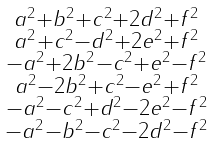Convert formula to latex. <formula><loc_0><loc_0><loc_500><loc_500>\begin{smallmatrix} a ^ { 2 } + b ^ { 2 } + c ^ { 2 } + 2 d ^ { 2 } + f ^ { 2 } \\ a ^ { 2 } + c ^ { 2 } - d ^ { 2 } + 2 e ^ { 2 } + f ^ { 2 } \\ - a ^ { 2 } + 2 b ^ { 2 } - c ^ { 2 } + e ^ { 2 } - f ^ { 2 } \\ a ^ { 2 } - 2 b ^ { 2 } + c ^ { 2 } - e ^ { 2 } + f ^ { 2 } \\ - a ^ { 2 } - c ^ { 2 } + d ^ { 2 } - 2 e ^ { 2 } - f ^ { 2 } \\ - a ^ { 2 } - b ^ { 2 } - c ^ { 2 } - 2 d ^ { 2 } - f ^ { 2 } \end{smallmatrix}</formula> 